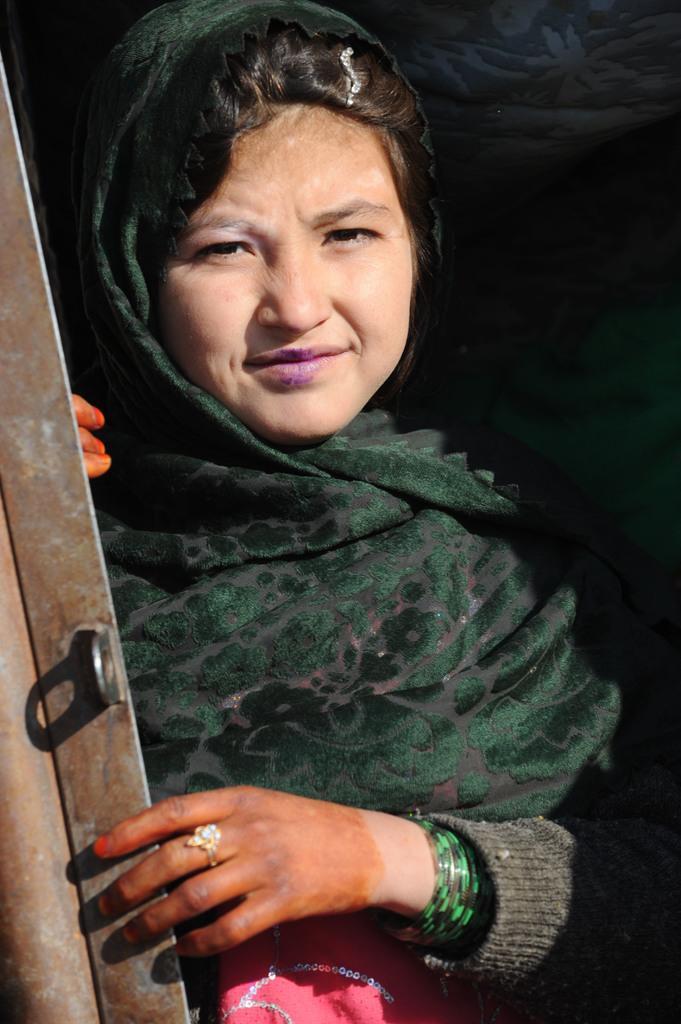Could you give a brief overview of what you see in this image? In this image in the front there is a woman smiling and on the left side there is a metal object. 